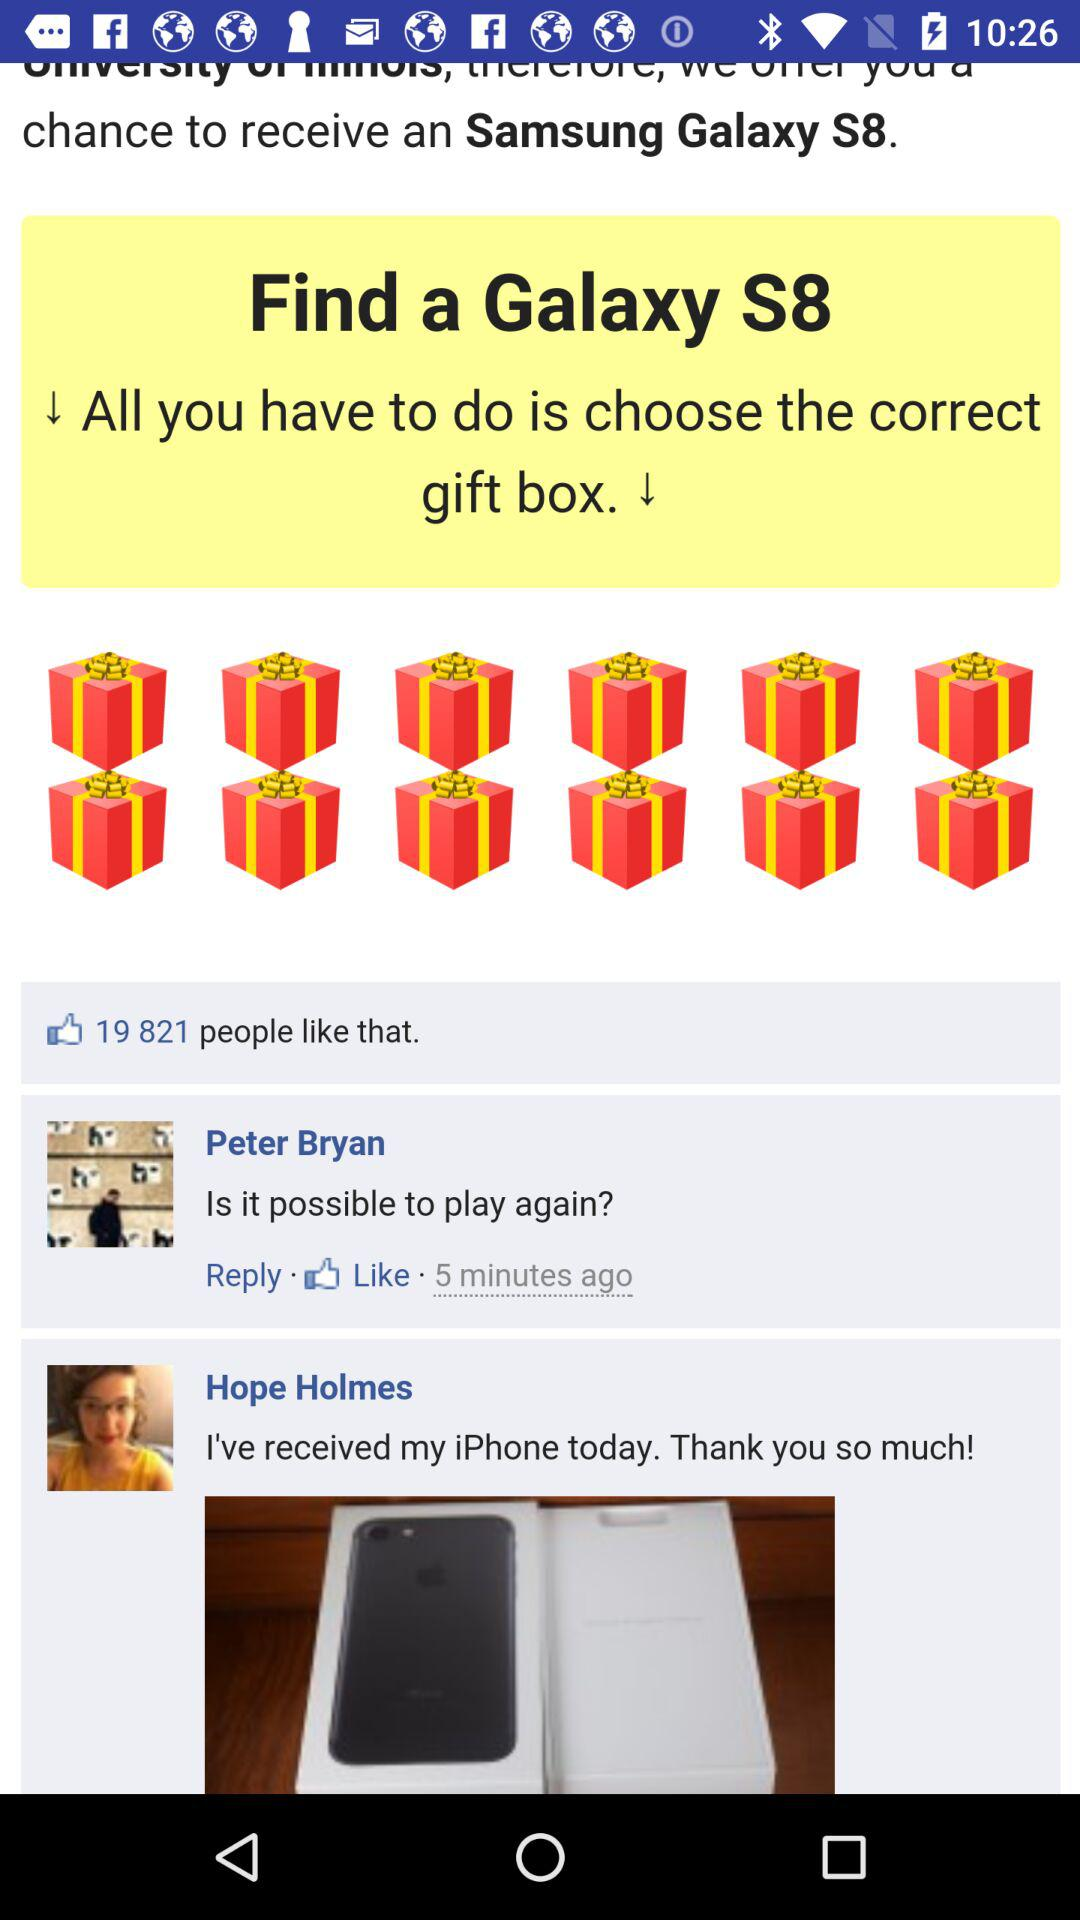Who received the iPhone? The iPhone was received by Hope Homes. 